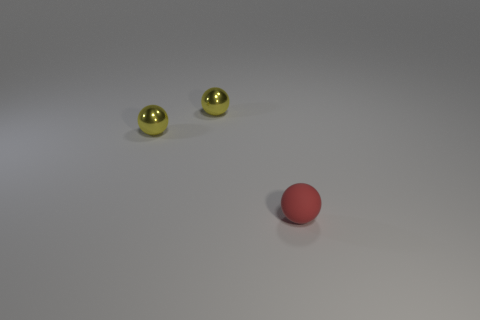Add 2 small red rubber things. How many objects exist? 5 Add 1 matte spheres. How many matte spheres exist? 2 Subtract 0 yellow cubes. How many objects are left? 3 Subtract all small red things. Subtract all tiny shiny things. How many objects are left? 0 Add 2 yellow balls. How many yellow balls are left? 4 